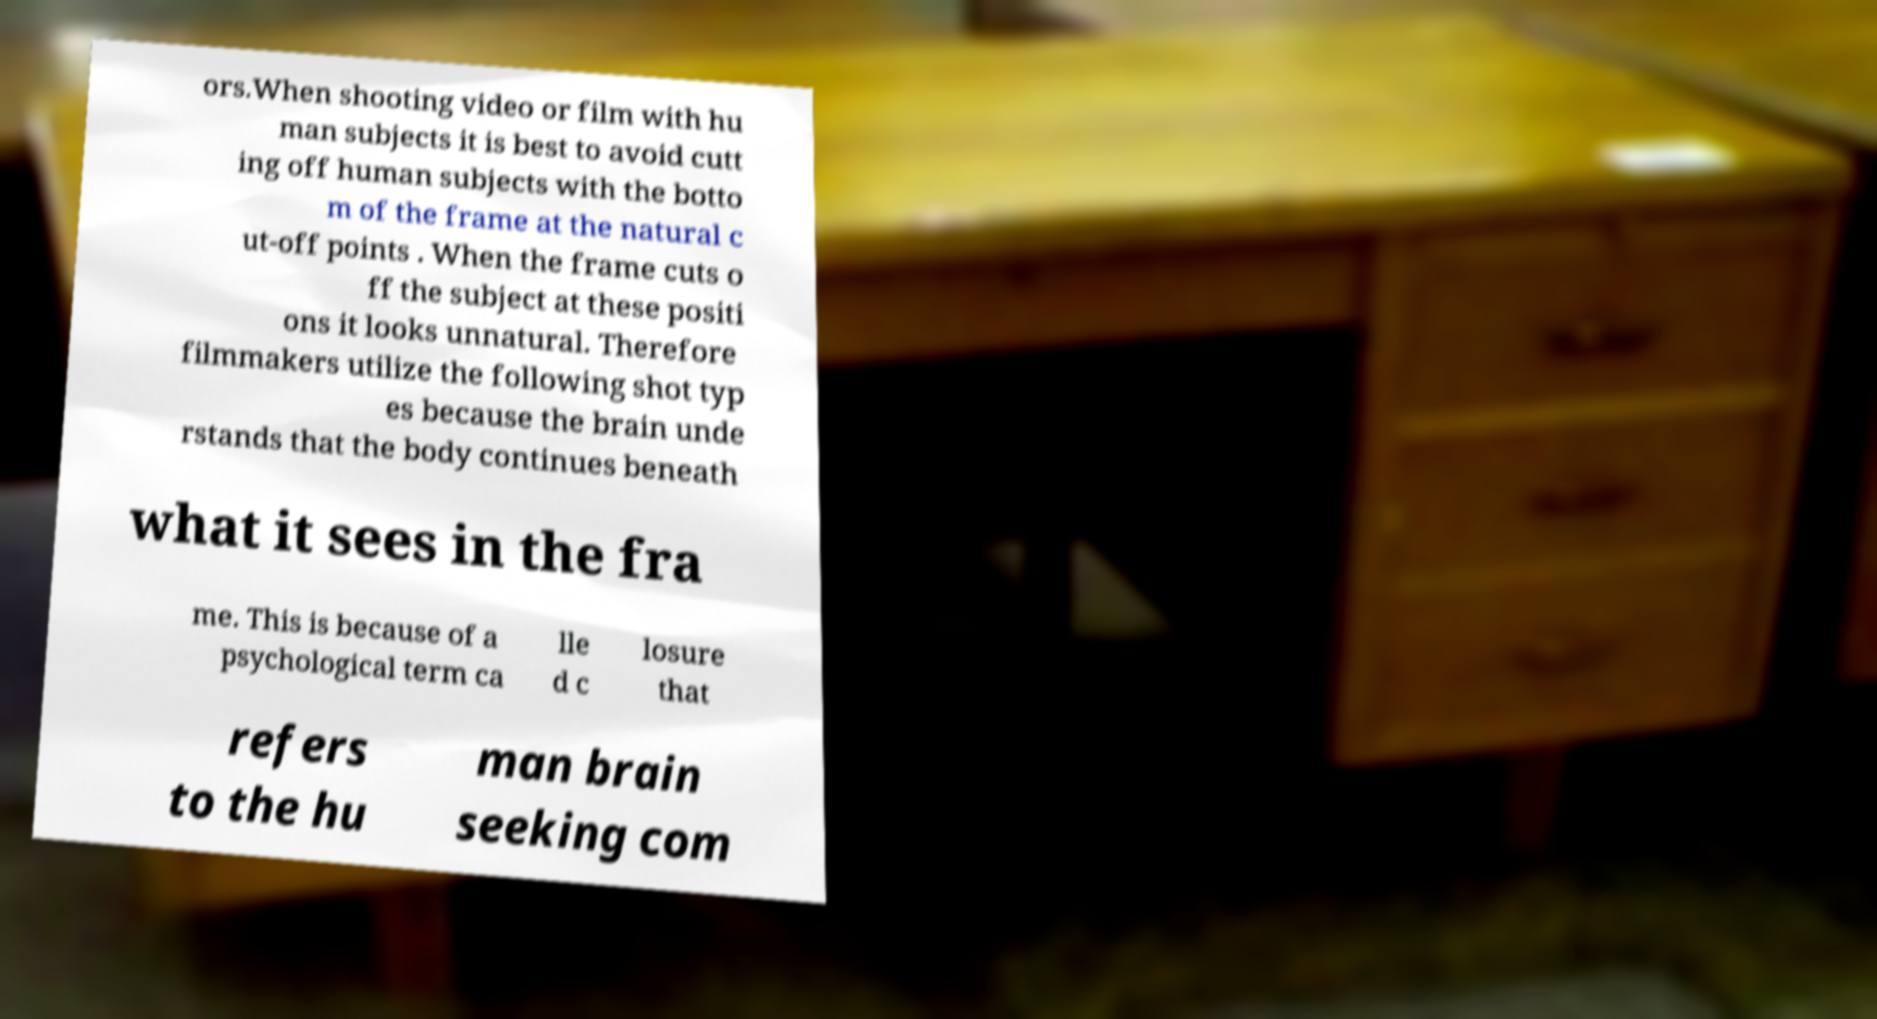What messages or text are displayed in this image? I need them in a readable, typed format. ors.When shooting video or film with hu man subjects it is best to avoid cutt ing off human subjects with the botto m of the frame at the natural c ut-off points . When the frame cuts o ff the subject at these positi ons it looks unnatural. Therefore filmmakers utilize the following shot typ es because the brain unde rstands that the body continues beneath what it sees in the fra me. This is because of a psychological term ca lle d c losure that refers to the hu man brain seeking com 